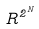<formula> <loc_0><loc_0><loc_500><loc_500>R ^ { 2 ^ { N } }</formula> 